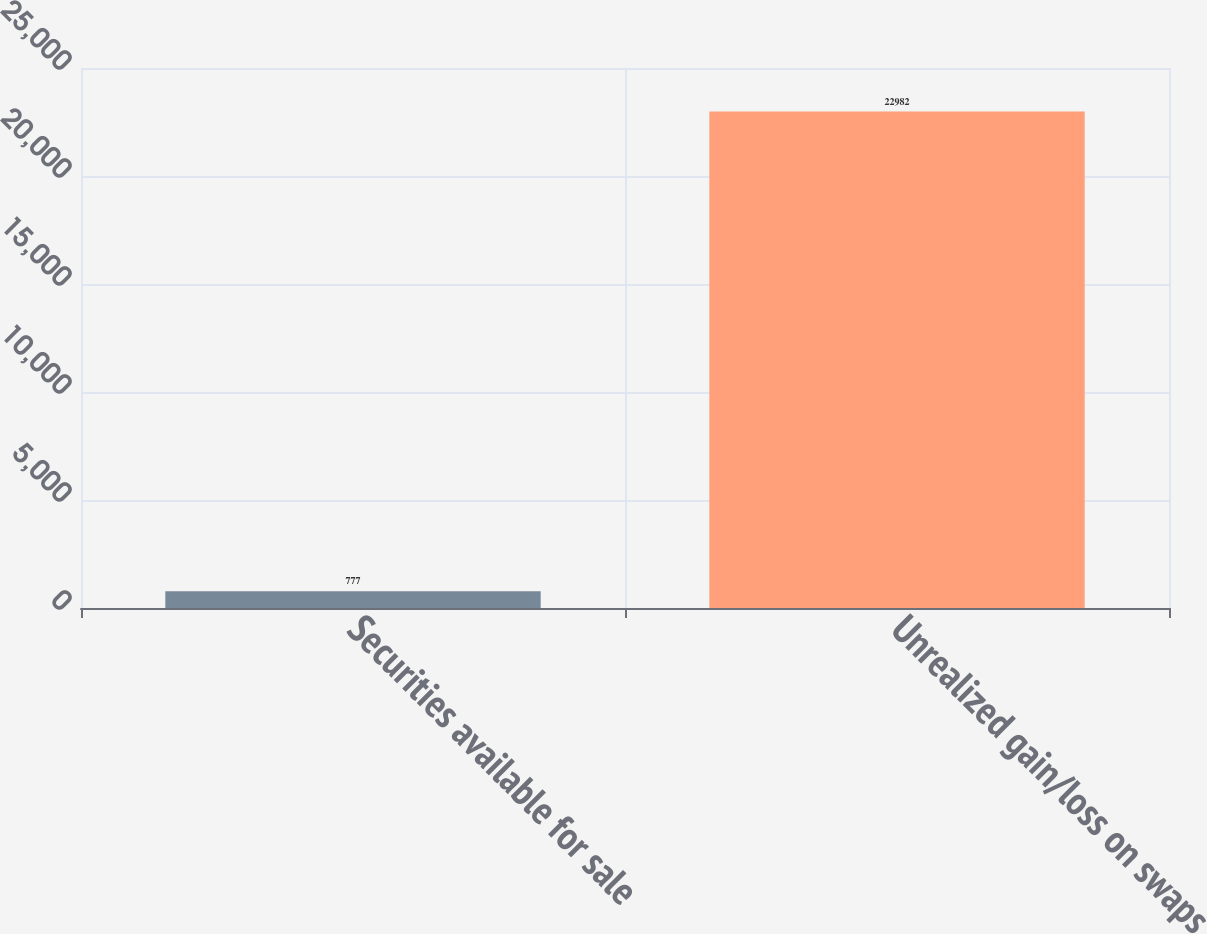<chart> <loc_0><loc_0><loc_500><loc_500><bar_chart><fcel>Securities available for sale<fcel>Unrealized gain/loss on swaps<nl><fcel>777<fcel>22982<nl></chart> 